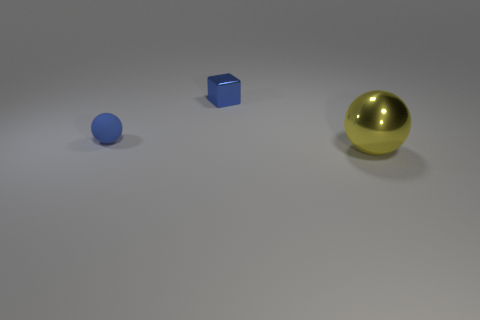There is a object that is the same color as the tiny metallic cube; what is it made of?
Give a very brief answer. Rubber. Do the metal cube and the yellow object have the same size?
Your answer should be very brief. No. Is there a tiny blue object behind the ball to the left of the large yellow metal ball?
Your response must be concise. Yes. There is a rubber ball that is the same color as the small metal thing; what is its size?
Offer a terse response. Small. What is the shape of the shiny thing that is on the left side of the yellow sphere?
Provide a short and direct response. Cube. There is a thing that is behind the blue thing that is in front of the small blue metallic cube; how many rubber objects are in front of it?
Your answer should be very brief. 1. There is a blue matte thing; is it the same size as the metallic thing to the left of the large metal ball?
Offer a terse response. Yes. What size is the blue object in front of the shiny object on the left side of the yellow ball?
Ensure brevity in your answer.  Small. How many tiny spheres have the same material as the tiny cube?
Give a very brief answer. 0. Is there a big red matte block?
Provide a succinct answer. No. 